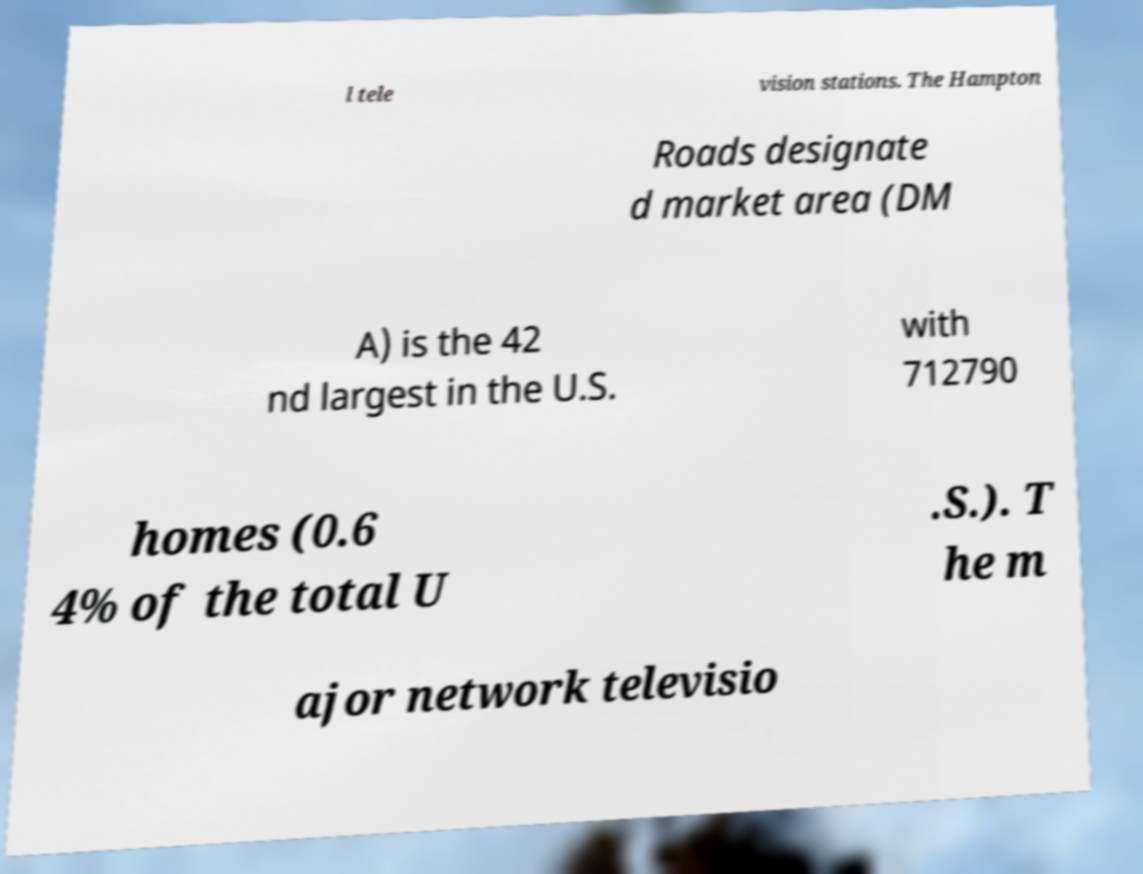Could you assist in decoding the text presented in this image and type it out clearly? l tele vision stations. The Hampton Roads designate d market area (DM A) is the 42 nd largest in the U.S. with 712790 homes (0.6 4% of the total U .S.). T he m ajor network televisio 